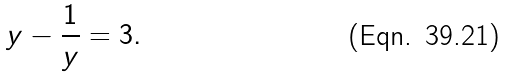Convert formula to latex. <formula><loc_0><loc_0><loc_500><loc_500>y - \frac { 1 } { y } = 3 .</formula> 